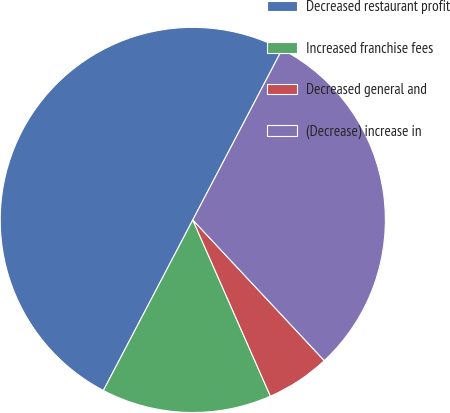<chart> <loc_0><loc_0><loc_500><loc_500><pie_chart><fcel>Decreased restaurant profit<fcel>Increased franchise fees<fcel>Decreased general and<fcel>(Decrease) increase in<nl><fcel>50.0%<fcel>14.29%<fcel>5.36%<fcel>30.36%<nl></chart> 